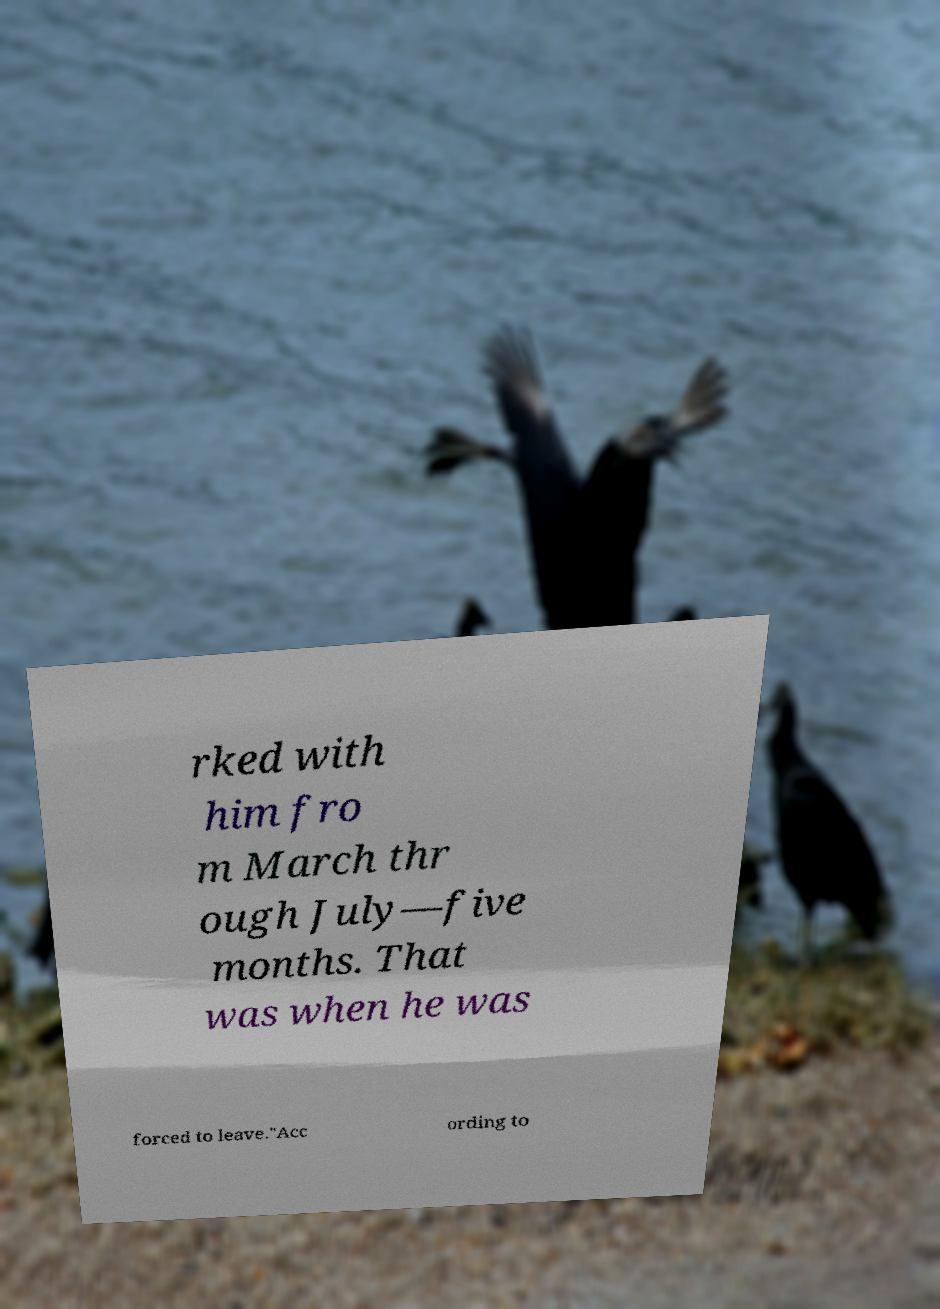Could you extract and type out the text from this image? rked with him fro m March thr ough July—five months. That was when he was forced to leave."Acc ording to 